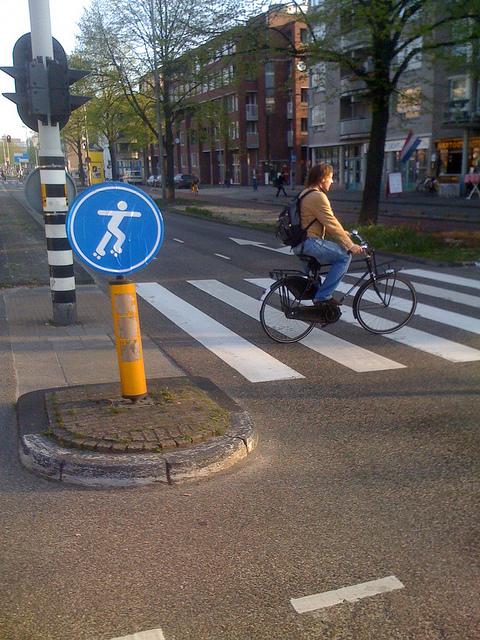What type of transportation is specifically identified for this crosswalk?
Be succinct. Roller skates. What kind of transportation is visible closest to the viewer?
Short answer required. Bicycle. What is the man riding on?
Be succinct. Bike. 